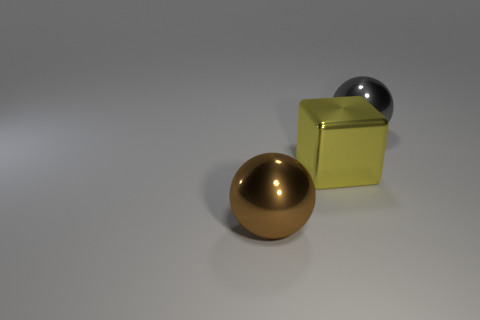What is the color of the cube?
Keep it short and to the point. Yellow. How many other things are the same color as the big shiny block?
Provide a succinct answer. 0. Are there any blocks to the right of the big gray ball?
Make the answer very short. No. The big ball that is behind the large shiny sphere in front of the gray metallic object that is behind the large yellow shiny object is what color?
Your answer should be very brief. Gray. What number of big things are both behind the large metal cube and in front of the large gray sphere?
Ensure brevity in your answer.  0. What number of cubes are either big yellow shiny objects or big rubber things?
Provide a succinct answer. 1. Are there any yellow objects?
Offer a very short reply. Yes. How many other things are the same material as the cube?
Your answer should be very brief. 2. What material is the gray thing that is the same size as the yellow shiny object?
Keep it short and to the point. Metal. There is a object behind the large yellow metallic cube; does it have the same shape as the brown object?
Make the answer very short. Yes. 